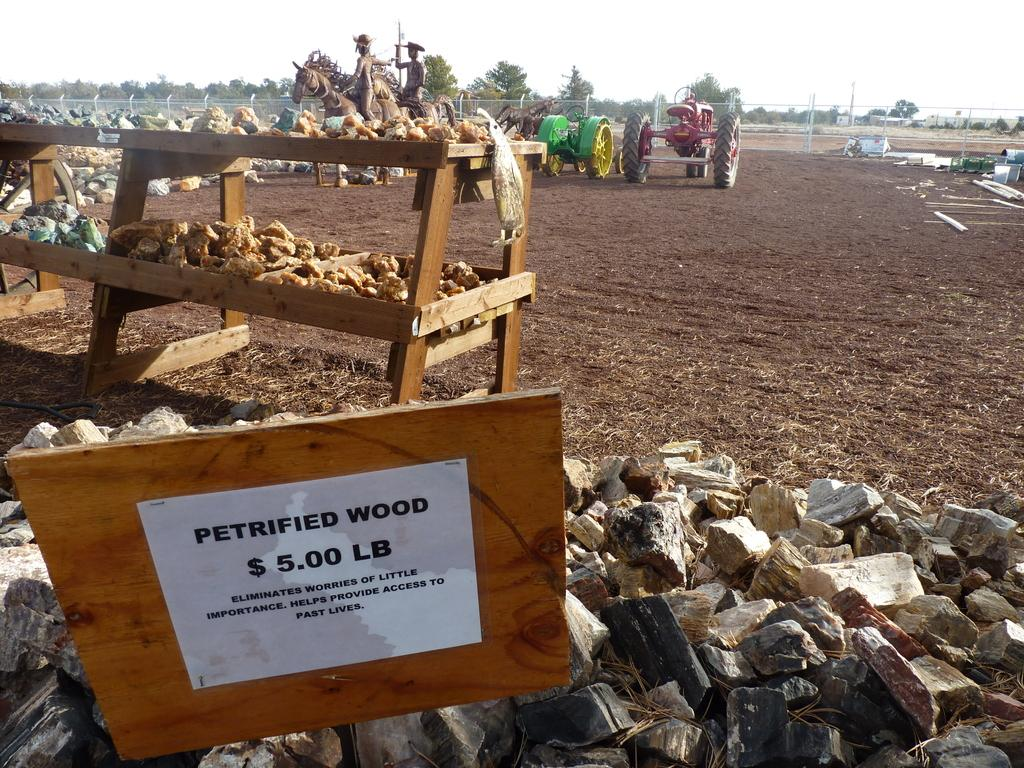<image>
Write a terse but informative summary of the picture. A sign says petrified wood at $5.00 per pound. 